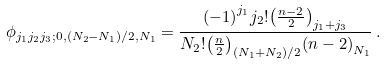<formula> <loc_0><loc_0><loc_500><loc_500>\phi _ { j _ { 1 } j _ { 2 } j _ { 3 } ; 0 , ( N _ { 2 } - N _ { 1 } ) / 2 , N _ { 1 } } = \frac { { ( - 1 ) } ^ { j _ { 1 } } j _ { 2 } ! { \left ( \frac { n - 2 } { 2 } \right ) } _ { j _ { 1 } + j _ { 3 } } } { N _ { 2 } ! { \left ( \frac { n } { 2 } \right ) } _ { ( N _ { 1 } + N _ { 2 } ) / 2 } { ( n - 2 ) } _ { N _ { 1 } } } \, .</formula> 